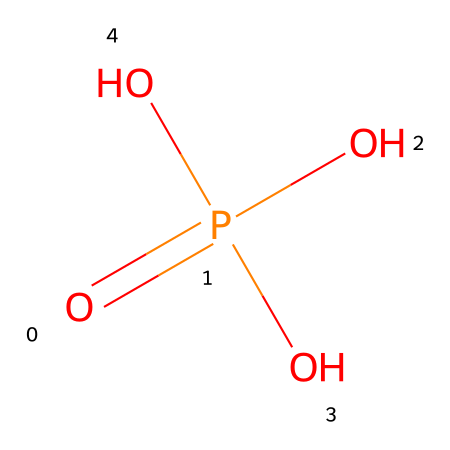What is the empirical formula of this compound? The SMILES representation indicates that the compound contains one phosphorus (P) atom and four oxygen (O) atoms, leading to the empirical formula of H3PO4, which can be derived from examining the structure.
Answer: H3PO4 How many hydroxyl groups are present in this molecule? Analyzing the SMILES notation, we see that there are three hydroxyl (-OH) groups indicated by the presence of three oxygen atoms bonded to hydrogen atoms, which are part of the structure.
Answer: 3 What is the central atom in this molecule? The structure shows a phosphorus atom surrounded by oxygen atoms, indicating that phosphorus is the central atom bonded to multiple functional groups.
Answer: phosphorus What is the total number of atoms in this compound? By counting the atoms from the SMILES notation, we see one phosphorus atom and four oxygen atoms, which sums up to five atoms total when considering implicit hydrogen atoms from the hydroxyl groups.
Answer: 7 What type of chemical reaction can phosphoric acid participate in? Phosphoric acid can act as a weak acid and readily donate protons (H+), which is a defining characteristic of acids. This is particularly connected to the hydroxyl group structure in its SMILES representation as it can lose hydrogen ions.
Answer: acid-base reactions In what state of matter is phosphoric acid typically found? Phosphoric acid is commonly found as a viscous liquid at room temperature, as indicated by its properties as a laboratory reagent and its chemical structure which suggests a soluble liquid.
Answer: liquid 